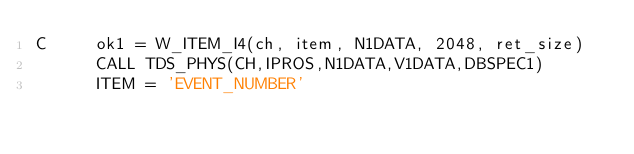Convert code to text. <code><loc_0><loc_0><loc_500><loc_500><_FORTRAN_>C	  ok1 = W_ITEM_I4(ch, item, N1DATA, 2048, ret_size)
	  CALL TDS_PHYS(CH,IPROS,N1DATA,V1DATA,DBSPEC1)
	  ITEM = 'EVENT_NUMBER'</code> 